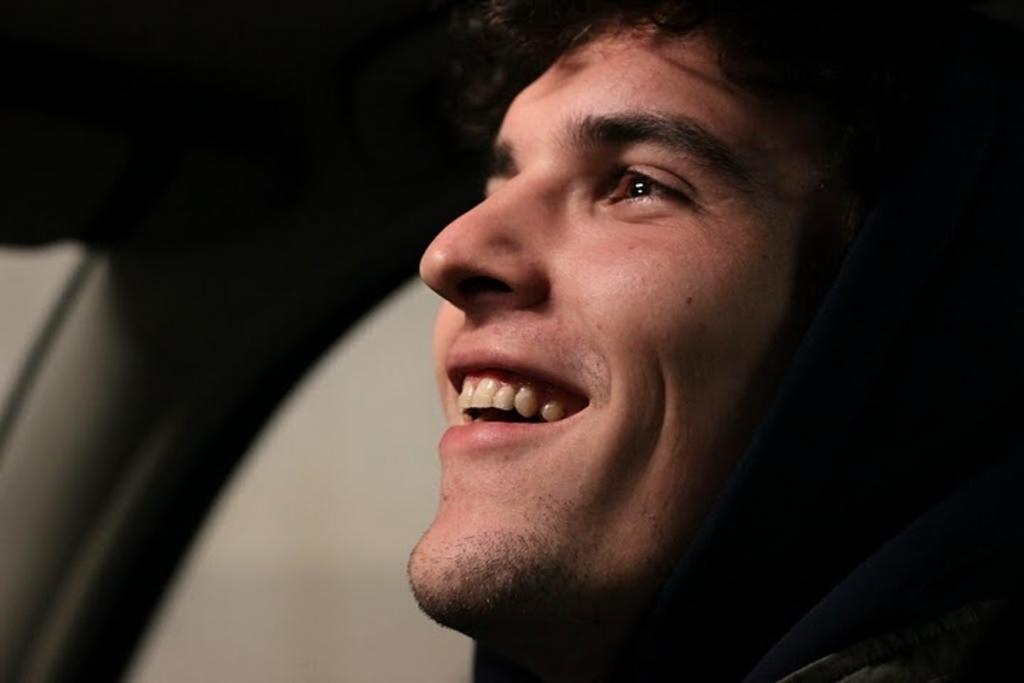Who is present in the image? There is a man in the image. What expression does the man have? The man is smiling. What can be observed about the background of the image? The background of the image is dark. What type of breakfast is the man eating in the image? There is no breakfast present in the image, as it only features a man with a smiling expression and a dark background. 